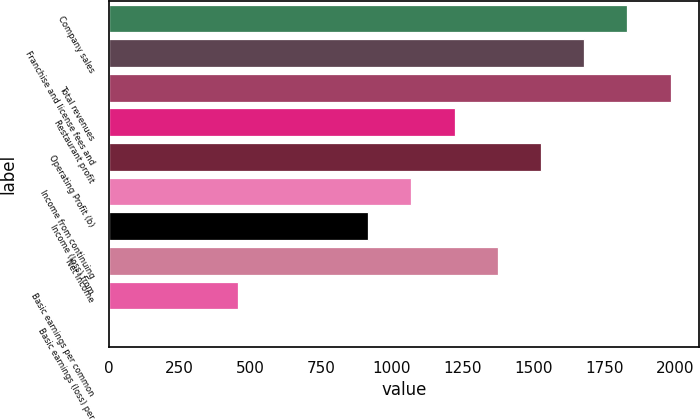Convert chart. <chart><loc_0><loc_0><loc_500><loc_500><bar_chart><fcel>Company sales<fcel>Franchise and license fees and<fcel>Total revenues<fcel>Restaurant profit<fcel>Operating Profit (b)<fcel>Income from continuing<fcel>Income (loss) from<fcel>Net Income<fcel>Basic earnings per common<fcel>Basic earnings (loss) per<nl><fcel>1831.19<fcel>1678.61<fcel>1983.78<fcel>1220.85<fcel>1526.02<fcel>1068.26<fcel>915.68<fcel>1373.43<fcel>457.91<fcel>0.15<nl></chart> 